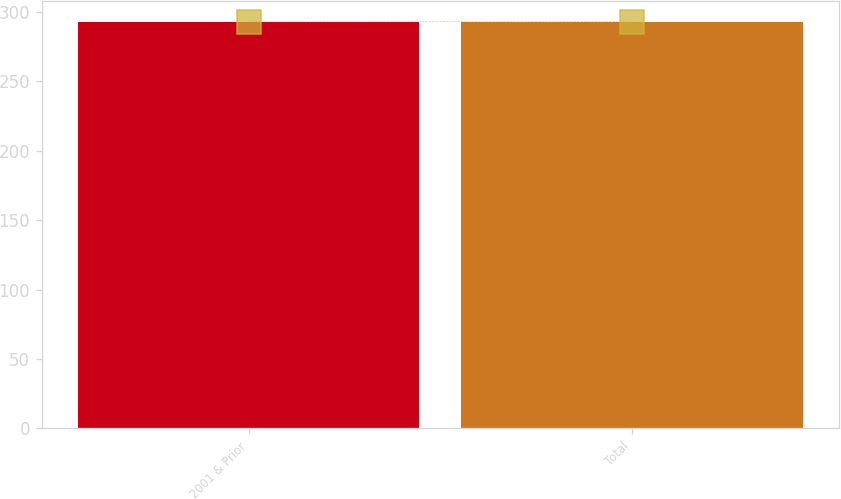<chart> <loc_0><loc_0><loc_500><loc_500><bar_chart><fcel>2001 & Prior<fcel>Total<nl><fcel>293<fcel>293.1<nl></chart> 